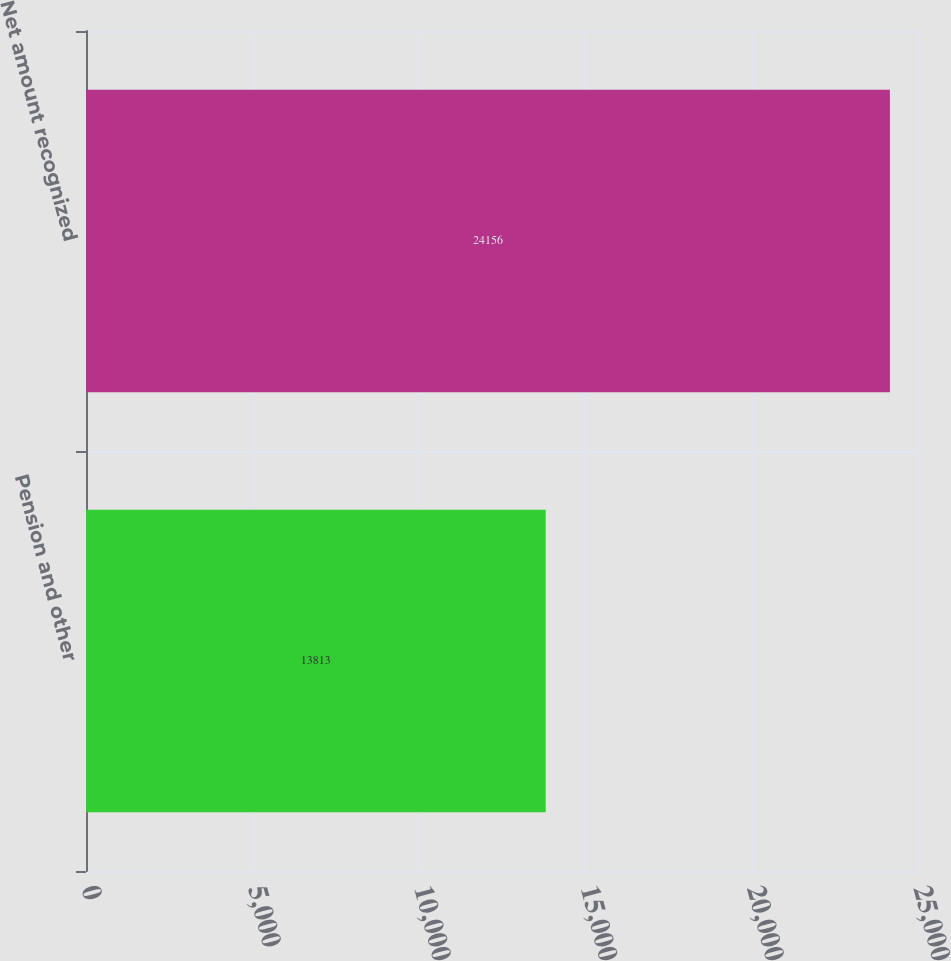Convert chart. <chart><loc_0><loc_0><loc_500><loc_500><bar_chart><fcel>Pension and other<fcel>Net amount recognized<nl><fcel>13813<fcel>24156<nl></chart> 